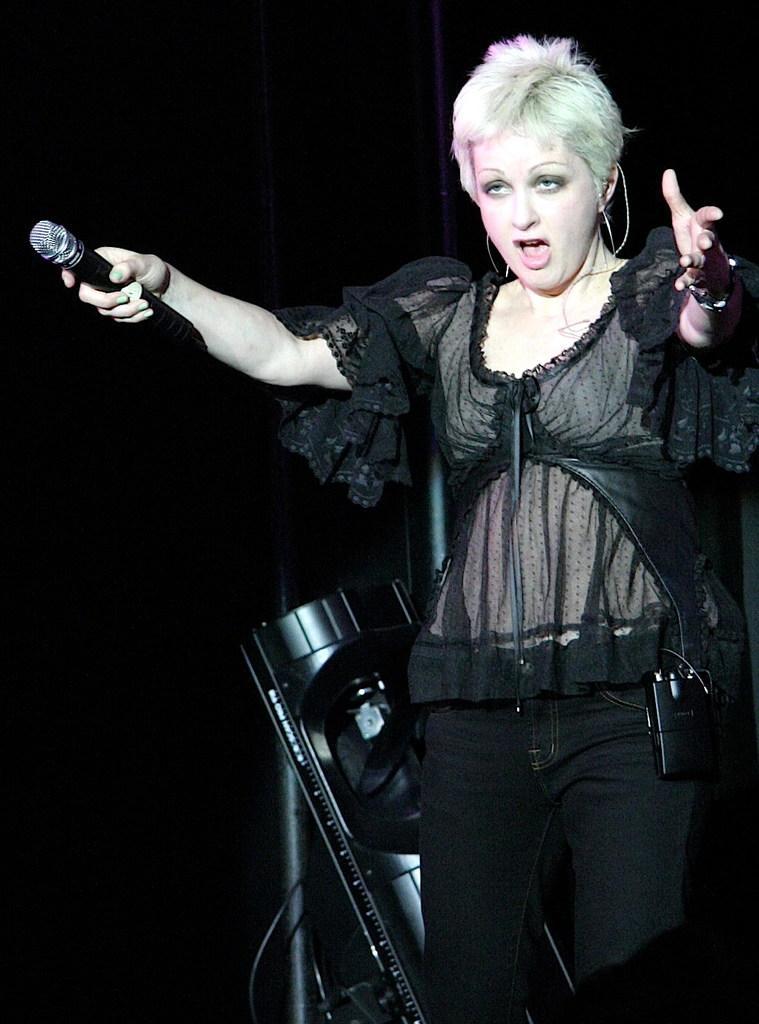How would you summarize this image in a sentence or two? In this image we can see a woman standing and holding a mic, behind her we can see an object and the background is dark. 